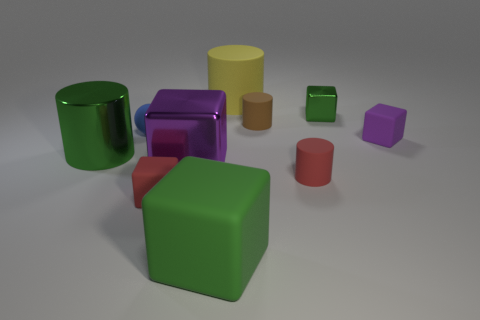There is a matte block that is to the right of the green cube that is in front of the large green metal cylinder; what color is it?
Your response must be concise. Purple. Is the number of large green metal things that are on the right side of the tiny purple thing less than the number of green cylinders that are in front of the red cylinder?
Your response must be concise. No. There is a object that is the same color as the big metallic block; what material is it?
Keep it short and to the point. Rubber. What number of objects are matte cubes that are to the right of the big yellow matte cylinder or brown objects?
Keep it short and to the point. 2. There is a block that is behind the brown matte thing; is it the same size as the large green matte object?
Provide a succinct answer. No. Are there fewer big purple objects behind the big yellow rubber cylinder than tiny red matte objects?
Offer a very short reply. Yes. There is a red cylinder that is the same size as the sphere; what is its material?
Your answer should be very brief. Rubber. How many tiny objects are either purple cylinders or red matte cylinders?
Provide a short and direct response. 1. What number of objects are either large rubber things that are behind the tiny brown object or tiny cylinders that are behind the small purple matte block?
Make the answer very short. 2. Are there fewer large purple blocks than small matte cylinders?
Keep it short and to the point. Yes. 